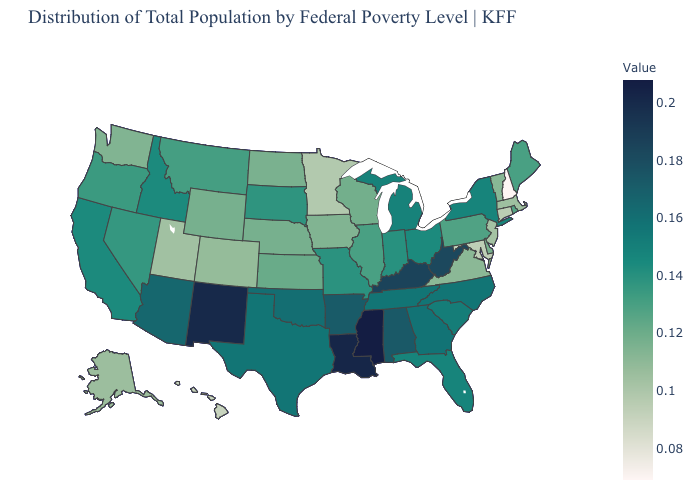Among the states that border Minnesota , which have the lowest value?
Write a very short answer. Iowa. Among the states that border Vermont , which have the lowest value?
Be succinct. New Hampshire. Does Indiana have the highest value in the MidWest?
Short answer required. No. Which states hav the highest value in the Northeast?
Keep it brief. New York. Does Oklahoma have a lower value than New Mexico?
Give a very brief answer. Yes. Among the states that border Vermont , does New Hampshire have the lowest value?
Short answer required. Yes. 